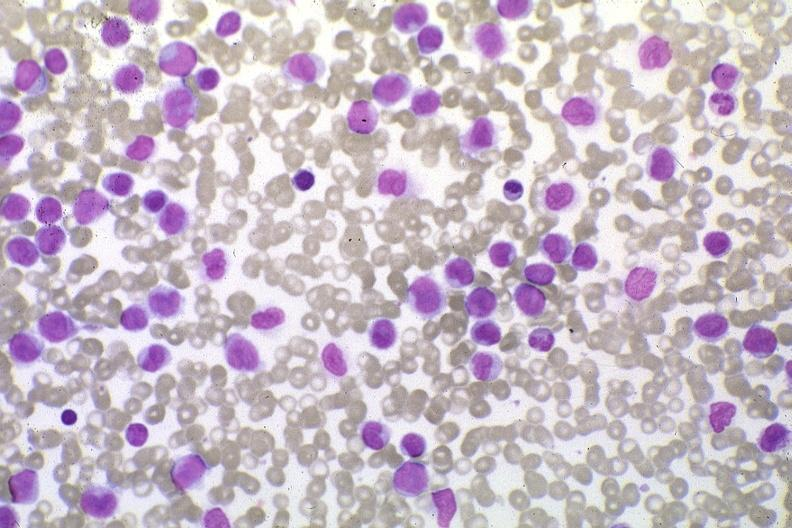what does this image show?
Answer the question using a single word or phrase. Wrights stain pleomorphic leukemic cells in peripheral blood prior to therapy 